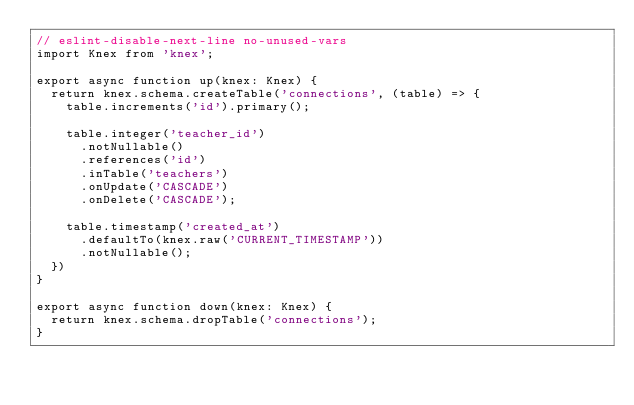Convert code to text. <code><loc_0><loc_0><loc_500><loc_500><_TypeScript_>// eslint-disable-next-line no-unused-vars
import Knex from 'knex';

export async function up(knex: Knex) {
  return knex.schema.createTable('connections', (table) => {
    table.increments('id').primary();

    table.integer('teacher_id')
      .notNullable()
      .references('id')
      .inTable('teachers')
      .onUpdate('CASCADE')
      .onDelete('CASCADE');

    table.timestamp('created_at')
      .defaultTo(knex.raw('CURRENT_TIMESTAMP'))
      .notNullable();
  })
}

export async function down(knex: Knex) {
  return knex.schema.dropTable('connections');
}</code> 